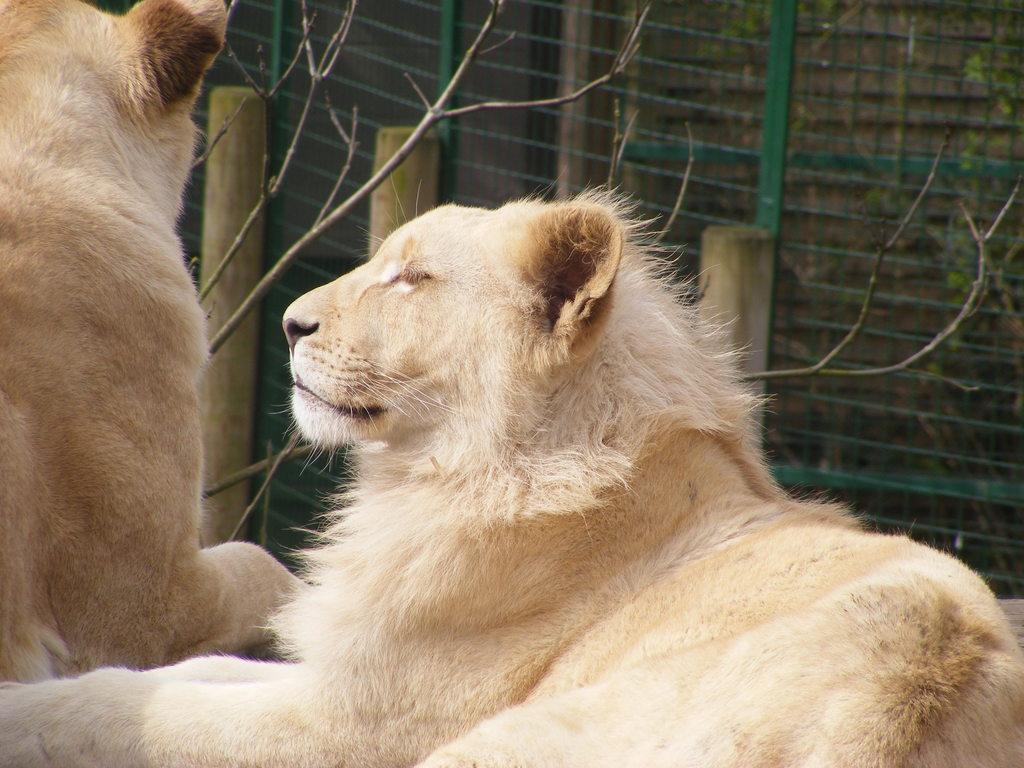How would you summarize this image in a sentence or two? In this image we can see lions. In the background, we can see bamboo, mesh and plants. 